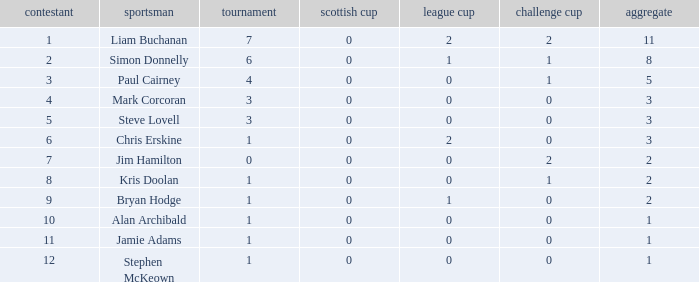How many points did player 7 score in the challenge cup? 1.0. 